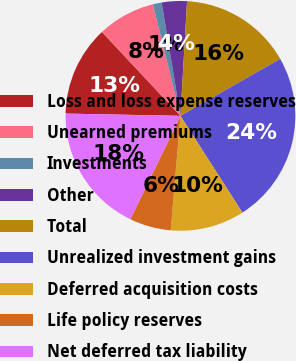<chart> <loc_0><loc_0><loc_500><loc_500><pie_chart><fcel>Loss and loss expense reserves<fcel>Unearned premiums<fcel>Investments<fcel>Other<fcel>Total<fcel>Unrealized investment gains<fcel>Deferred acquisition costs<fcel>Life policy reserves<fcel>Net deferred tax liability<nl><fcel>12.71%<fcel>8.12%<fcel>1.24%<fcel>3.53%<fcel>15.83%<fcel>24.19%<fcel>10.42%<fcel>5.83%<fcel>18.13%<nl></chart> 